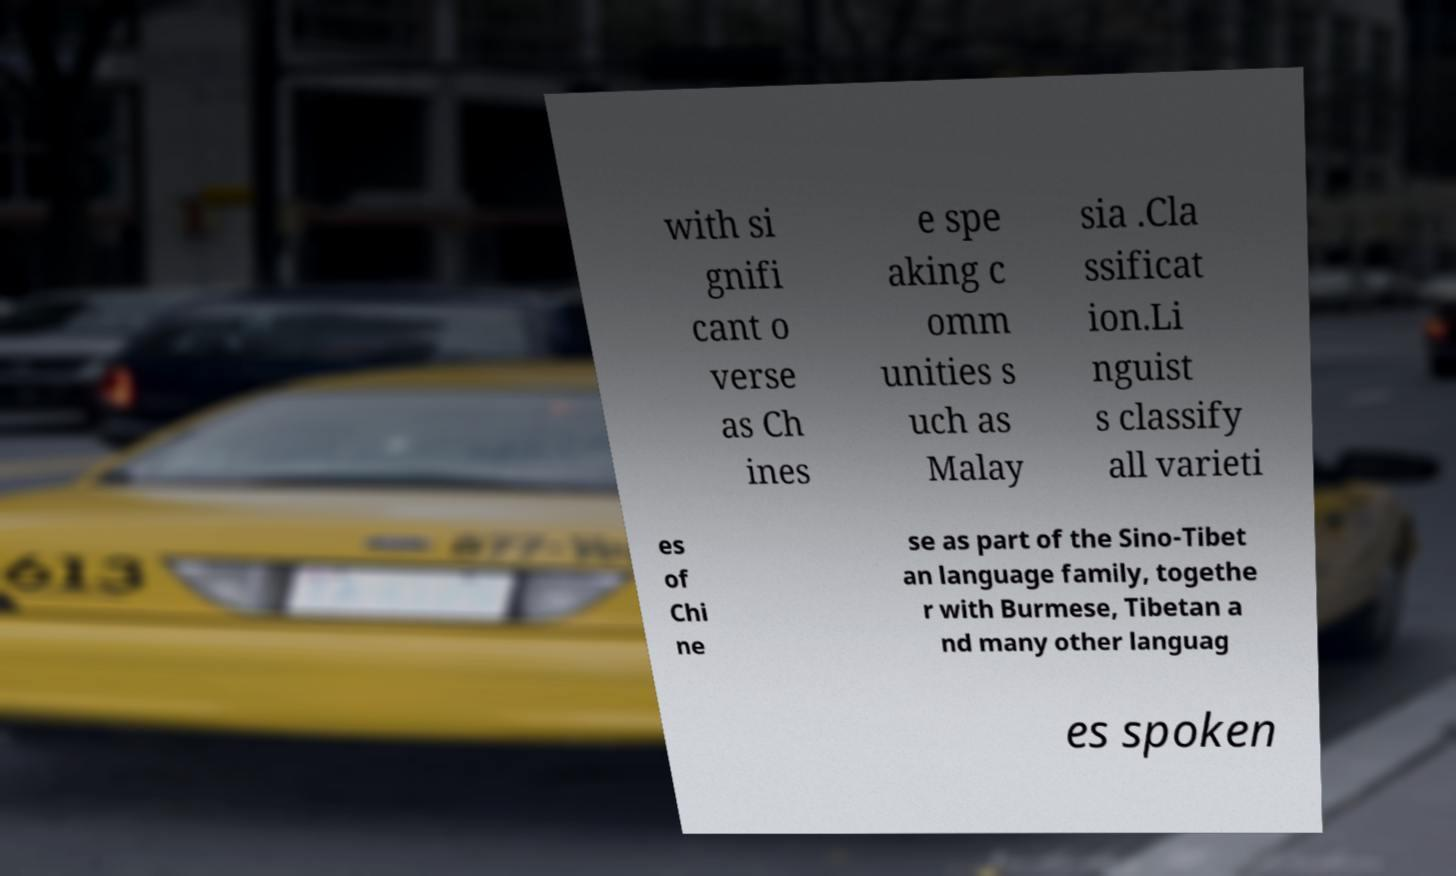Could you extract and type out the text from this image? with si gnifi cant o verse as Ch ines e spe aking c omm unities s uch as Malay sia .Cla ssificat ion.Li nguist s classify all varieti es of Chi ne se as part of the Sino-Tibet an language family, togethe r with Burmese, Tibetan a nd many other languag es spoken 